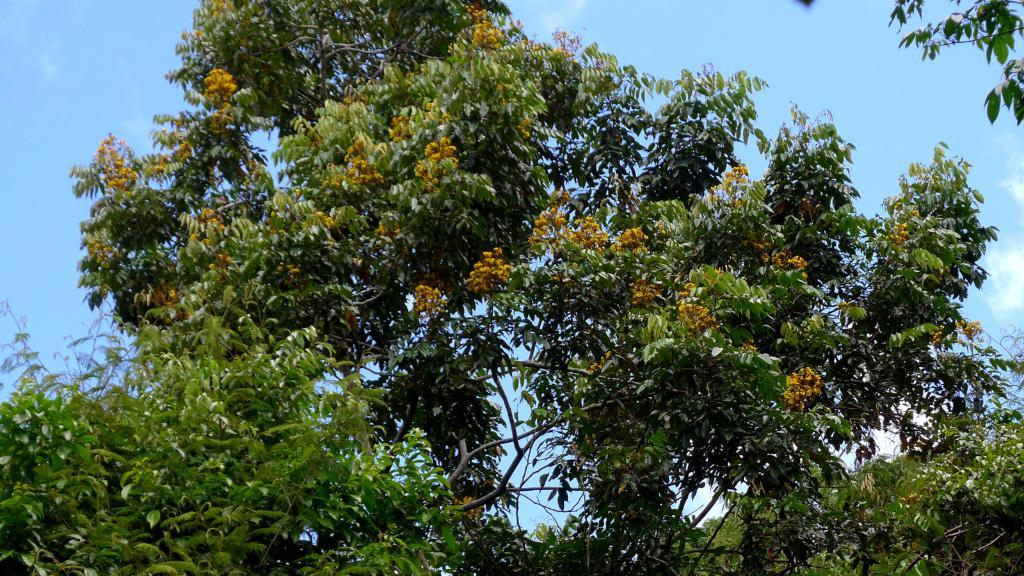What type of vegetation can be seen in the image? There are trees in the image. What part of the natural environment is visible in the image? The sky is visible in the background of the image. How many kittens are wearing trousers and guiding the trees in the image? There are no kittens or trousers present in the image, and therefore no such activity can be observed. 